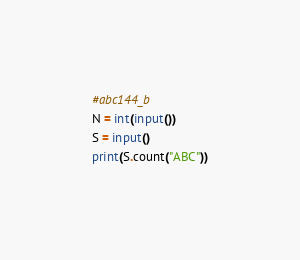<code> <loc_0><loc_0><loc_500><loc_500><_Python_>#abc144_b
N = int(input())
S = input()
print(S.count("ABC"))</code> 